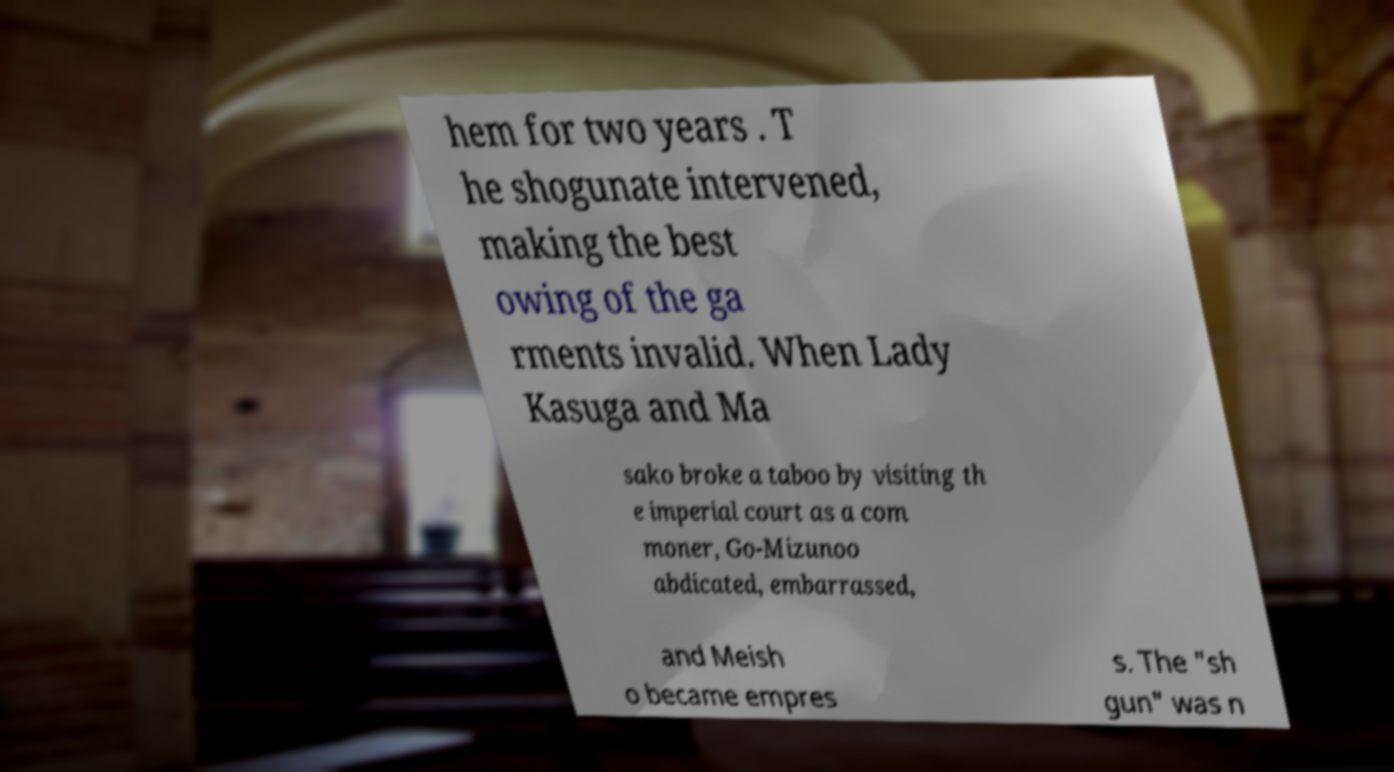What messages or text are displayed in this image? I need them in a readable, typed format. hem for two years . T he shogunate intervened, making the best owing of the ga rments invalid. When Lady Kasuga and Ma sako broke a taboo by visiting th e imperial court as a com moner, Go-Mizunoo abdicated, embarrassed, and Meish o became empres s. The "sh gun" was n 